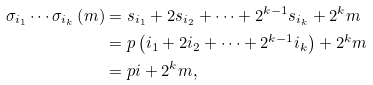Convert formula to latex. <formula><loc_0><loc_0><loc_500><loc_500>\sigma _ { i _ { 1 } } \cdots \sigma _ { i _ { k } } \left ( m \right ) & = s _ { i _ { 1 } } + 2 s _ { i _ { 2 } } + \dots + 2 ^ { k - 1 } s _ { i _ { k } } + 2 ^ { k } m \\ & = p \left ( i _ { 1 } + 2 i _ { 2 } + \dots + 2 ^ { k - 1 } i _ { k } \right ) + 2 ^ { k } m \\ & = p i + 2 ^ { k } m \text {,}</formula> 